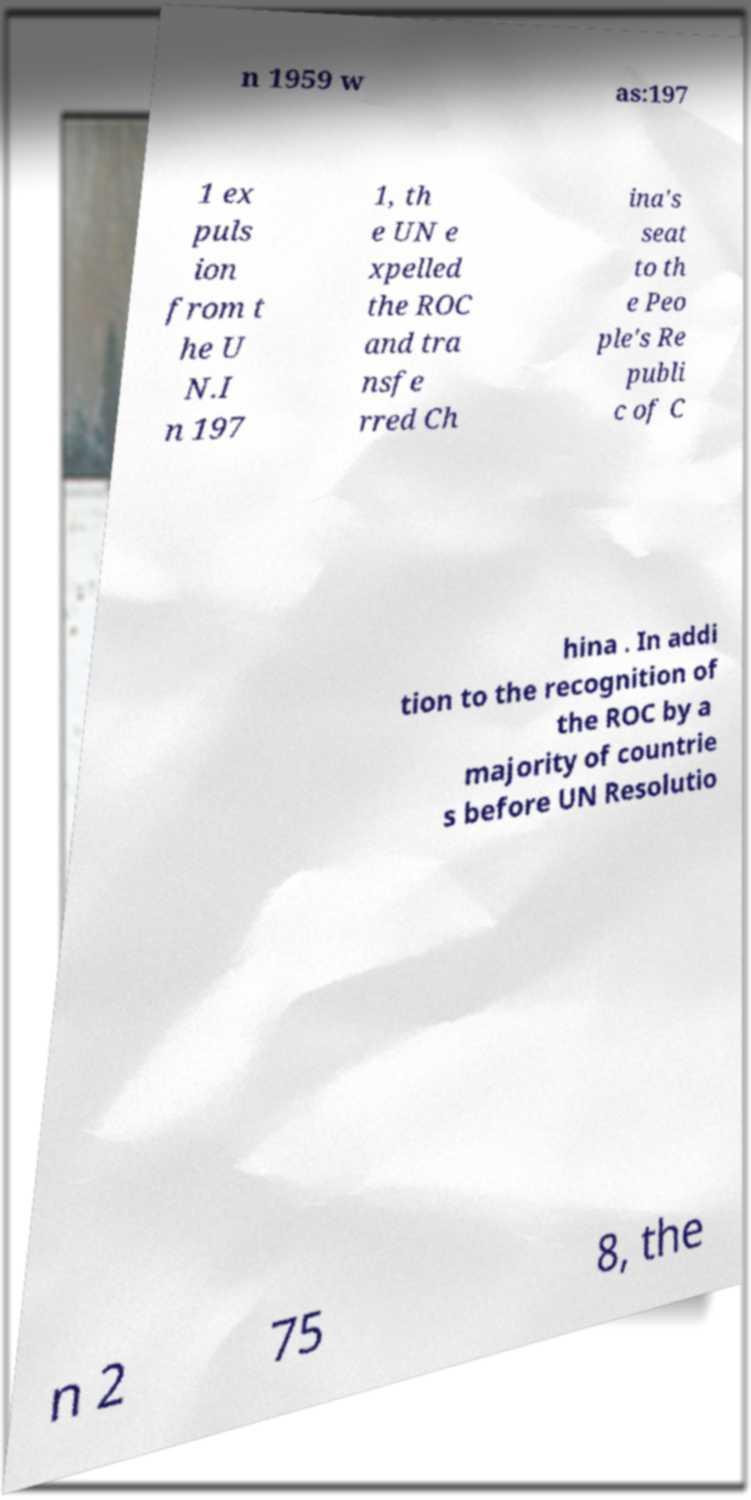What messages or text are displayed in this image? I need them in a readable, typed format. n 1959 w as:197 1 ex puls ion from t he U N.I n 197 1, th e UN e xpelled the ROC and tra nsfe rred Ch ina's seat to th e Peo ple's Re publi c of C hina . In addi tion to the recognition of the ROC by a majority of countrie s before UN Resolutio n 2 75 8, the 